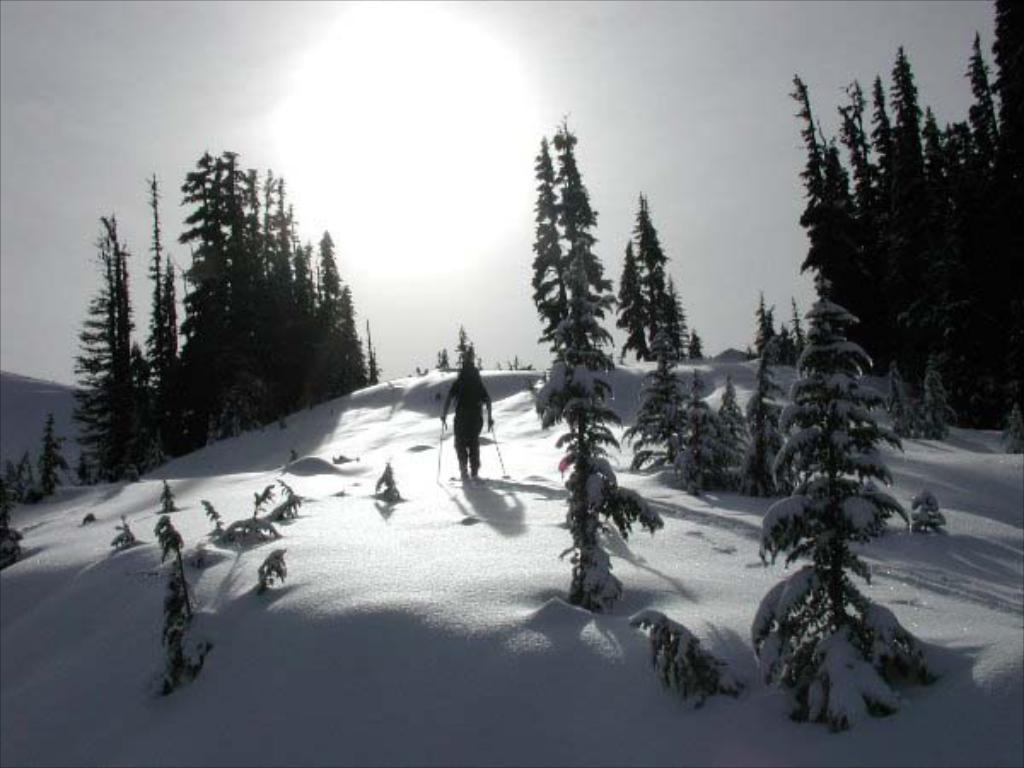What activity is the person in the image engaged in? The person is skating on land covered with ice. What can be seen on both sides of the image? Trees are present on both sides of the image. What is the condition of the sky in the image? The sky is covered with clouds. What type of book is the person reading while skating in the image? There is no book present in the image, and the person is not reading while skating. 